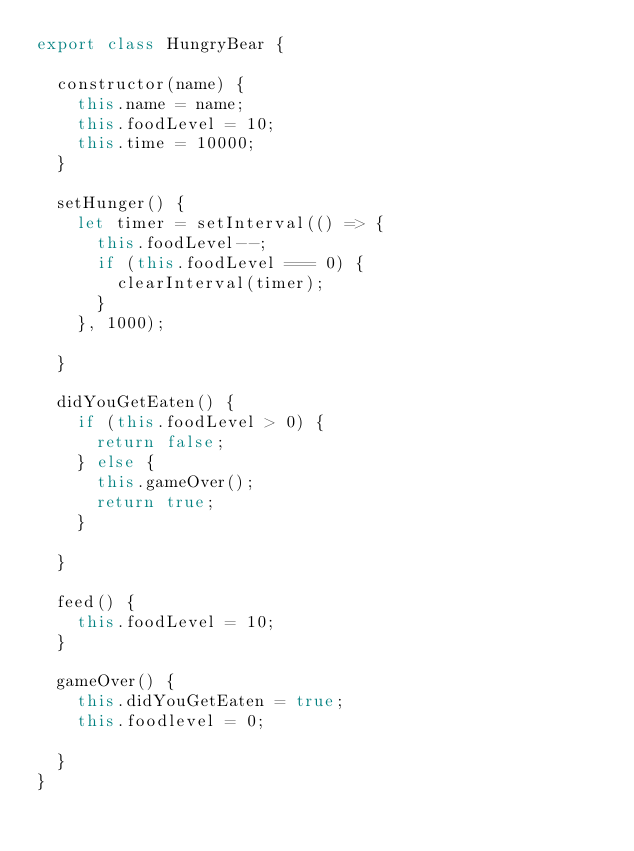Convert code to text. <code><loc_0><loc_0><loc_500><loc_500><_JavaScript_>export class HungryBear {

  constructor(name) {
    this.name = name;
    this.foodLevel = 10;
    this.time = 10000;
  }

  setHunger() {
    let timer = setInterval(() => {
      this.foodLevel--;
      if (this.foodLevel === 0) {
        clearInterval(timer);
      }
    }, 1000);

  }

  didYouGetEaten() {
    if (this.foodLevel > 0) {
      return false;
    } else {
      this.gameOver();
      return true;
    }

  }

  feed() {
    this.foodLevel = 10;
  }

  gameOver() {
    this.didYouGetEaten = true;
    this.foodlevel = 0;

  }
}
</code> 